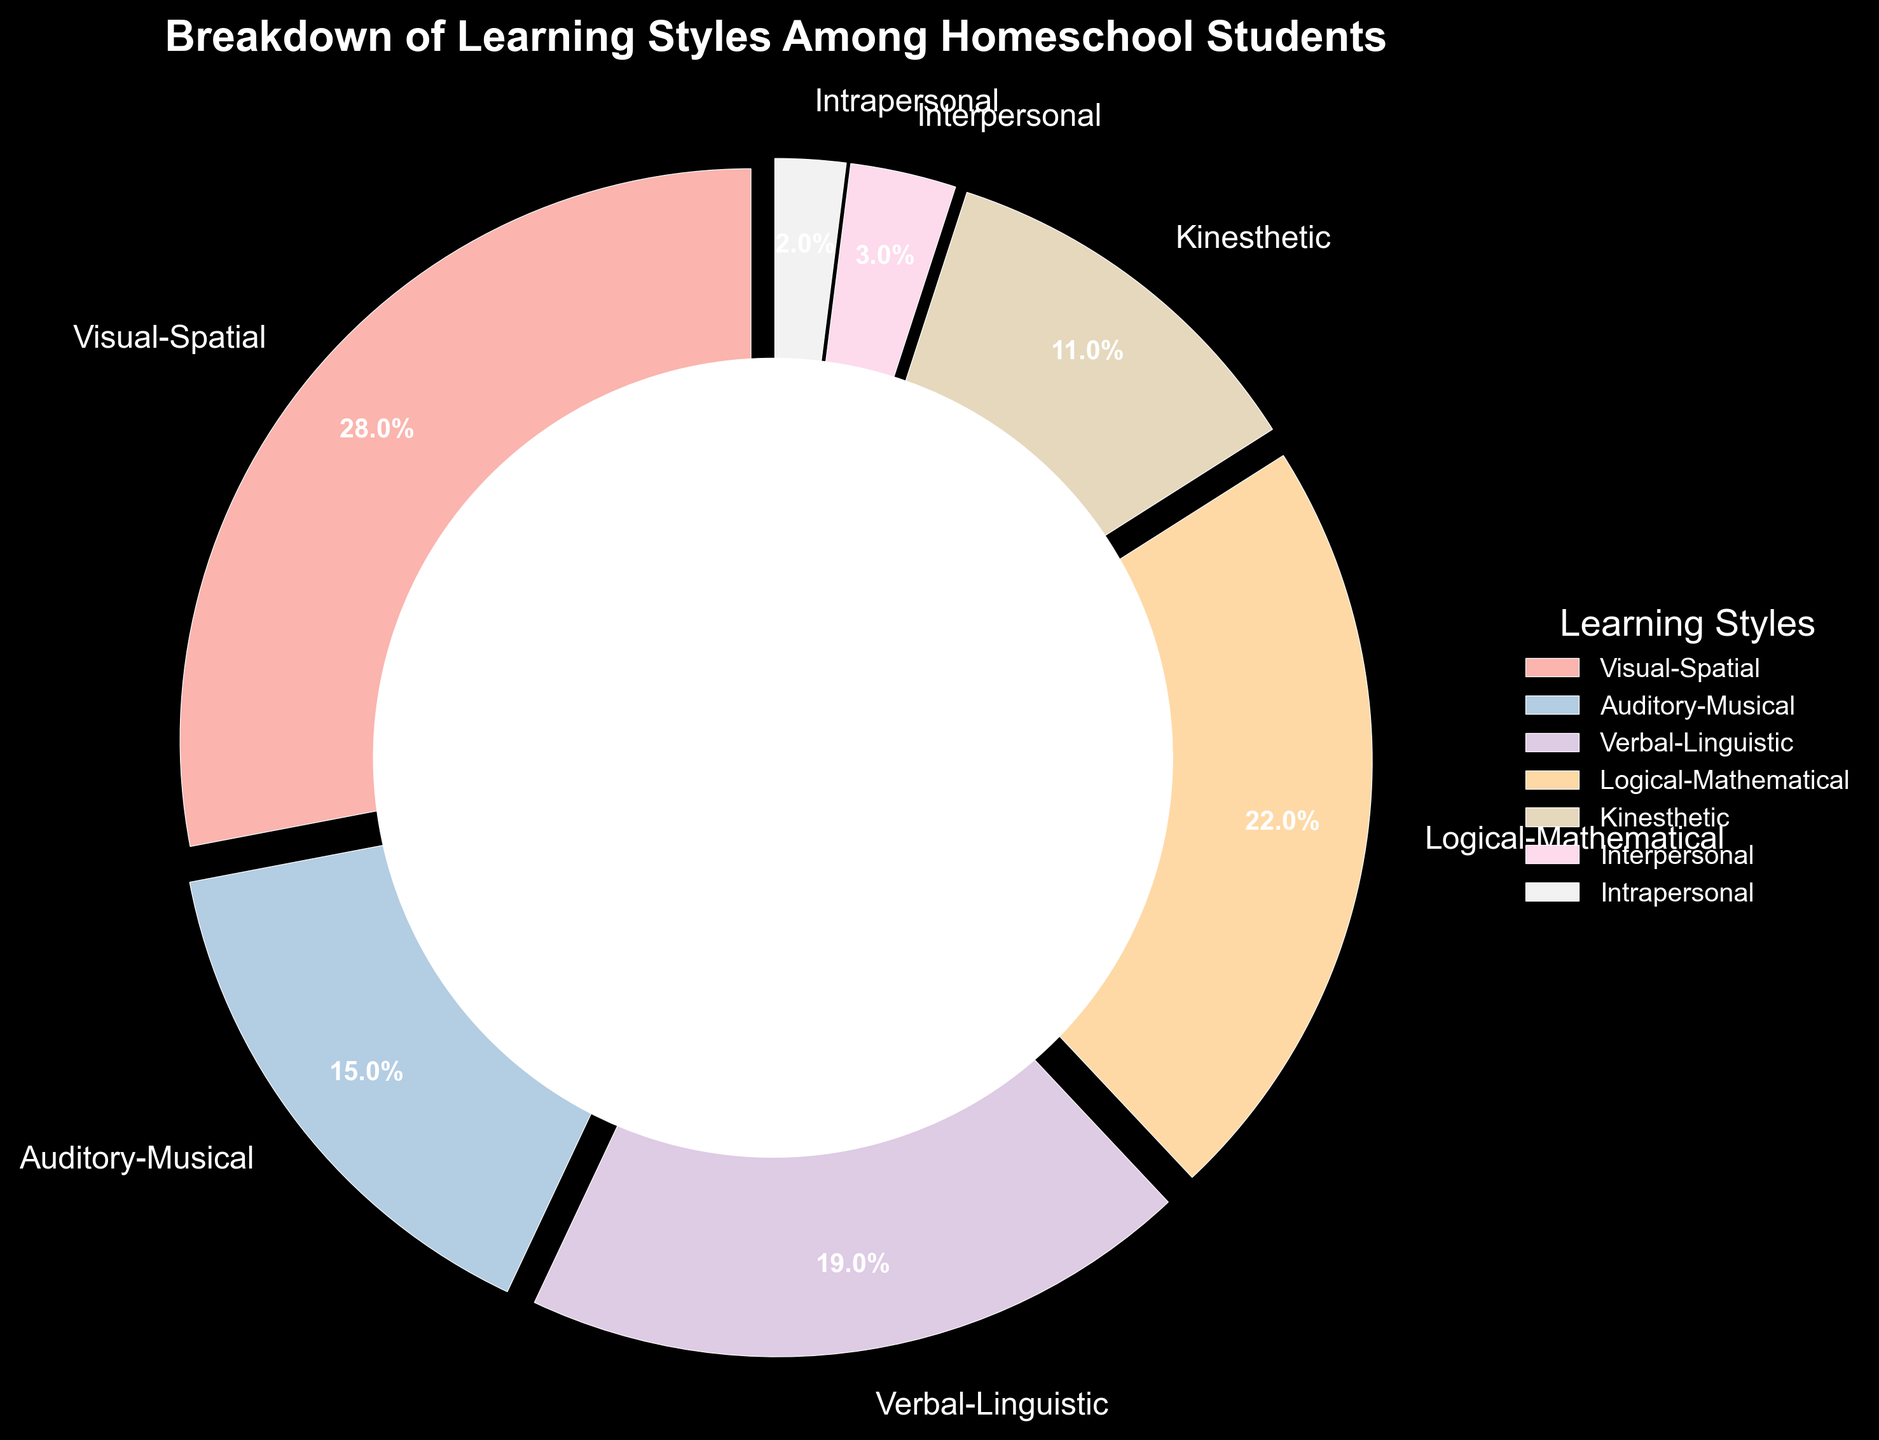What is the largest learning style group? The largest sector of the pie chart will have the largest percentage. Visual-Spatial has the largest sector with 28%.
Answer: Visual-Spatial Which learning style has the smallest percentage? The smallest sector of the pie chart will represent the smallest learning style group. Intrapersonal has the smallest sector with 2%.
Answer: Intrapersonal What is the combined percentage of Visual-Spatial and Logical-Mathematical learning styles? Add the percentages of Visual-Spatial and Logical-Mathematical: 28% + 22% = 50%.
Answer: 50% How do the percentages of Kinesthetic and Auditory-Musical learning styles compare? Compare the size of the sectors for Kinesthetic and Auditory-Musical. Kinesthetic is 11% and Auditory-Musical is 15%, so Auditory-Musical is larger.
Answer: Auditory-Musical is larger What is the difference in percentage between Verbal-Linguistic and Interpersonal learning styles? Subtract the percentage of Interpersonal from Verbal-Linguistic: 19% - 3% = 16%.
Answer: 16% How many learning styles have percentages greater than 20%? Identify sectors with percentages larger than 20%. Both Visual-Spatial (28%) and Logical-Mathematical (22%) are greater than 20%.
Answer: 2 Which colors are used for the Logical-Mathematical and Kinesthetic learning styles in the chart? Observe the colors assigned to the Logical-Mathematical and Kinesthetic sectors in the pie chart.
Answer: pastel colors Are there more students with Interpersonal or Auditory-Musical learning styles? Compare the sizes of the sectors for Interpersonal (3%) and Auditory-Musical (15%). Auditory-Musical is larger.
Answer: Auditory-Musical What percentage of students prefer Kinesthetic and Intrapersonal learning styles combined? Add the percentages of Kinesthetic and Intrapersonal: 11% + 2% = 13%.
Answer: 13% 